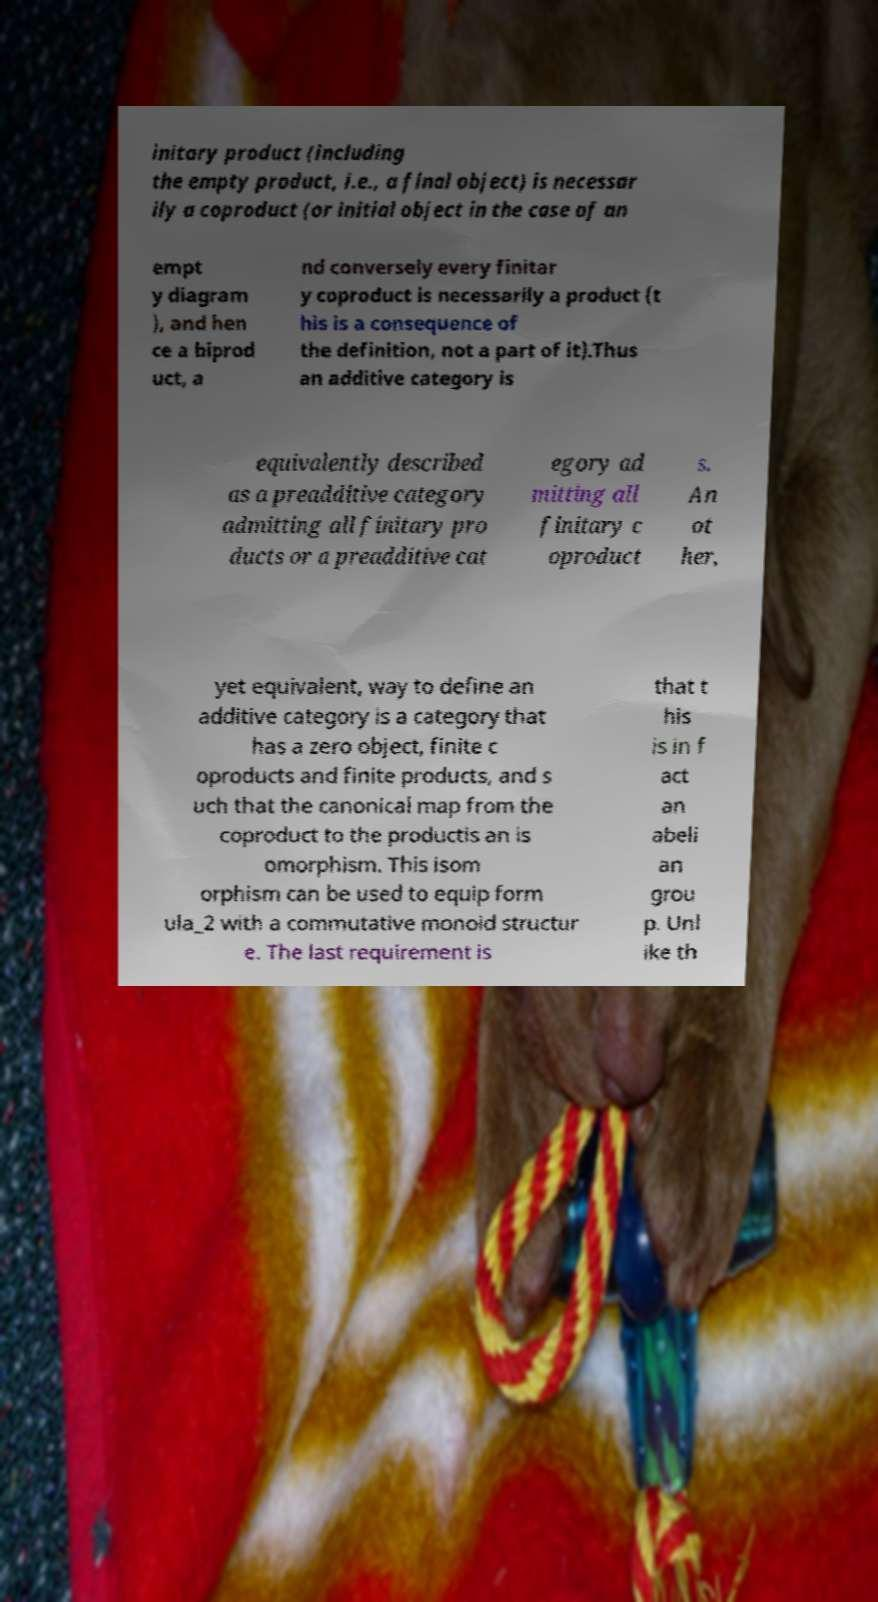I need the written content from this picture converted into text. Can you do that? initary product (including the empty product, i.e., a final object) is necessar ily a coproduct (or initial object in the case of an empt y diagram ), and hen ce a biprod uct, a nd conversely every finitar y coproduct is necessarily a product (t his is a consequence of the definition, not a part of it).Thus an additive category is equivalently described as a preadditive category admitting all finitary pro ducts or a preadditive cat egory ad mitting all finitary c oproduct s. An ot her, yet equivalent, way to define an additive category is a category that has a zero object, finite c oproducts and finite products, and s uch that the canonical map from the coproduct to the productis an is omorphism. This isom orphism can be used to equip form ula_2 with a commutative monoid structur e. The last requirement is that t his is in f act an abeli an grou p. Unl ike th 